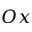<formula> <loc_0><loc_0><loc_500><loc_500>O x</formula> 